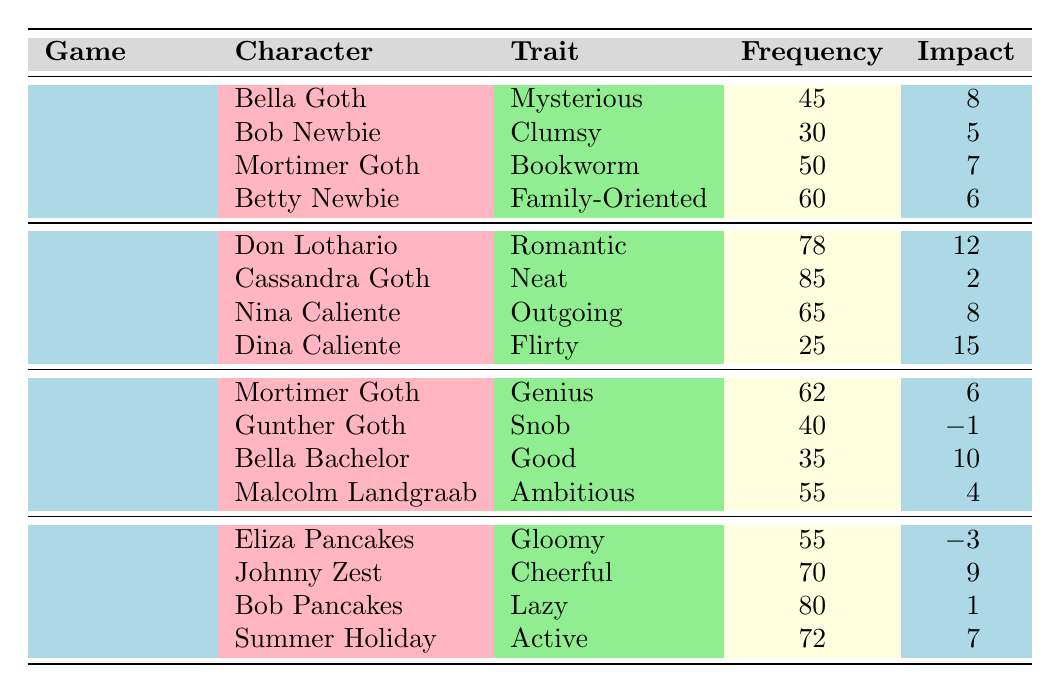What is the interaction with the highest frequency in The Sims 2? In The Sims 2, there are four characters listed. The frequencies of their interactions are: Don Lothario (78), Cassandra Goth (85), Nina Caliente (65), and Dina Caliente (25). The highest frequency is 85 associated with Cassandra Goth's interaction "Clean".
Answer: 85 Which character has the "Gloomy" trait in The Sims 4? In the table, under The Sims 4, the character listed with the "Gloomy" trait is Eliza Pancakes.
Answer: Eliza Pancakes What is the total frequency of interactions for characters in The Sims 3? The frequencies for The Sims 3 characters are: Mortimer Goth (62), Gunther Goth (40), Bella Bachelor (35), and Malcolm Landgraab (55). Adding these together gives: 62 + 40 + 35 + 55 = 192.
Answer: 192 Is there any character in The Sims 4 with a negative relationship impact? Looking at the relationship impact column for The Sims 4: Eliza Pancakes (-3), Johnny Zest (9), Bob Pancakes (1), and Summer Holiday (7). The presence of -3 for Eliza Pancakes confirms there is a character with a negative relationship impact.
Answer: Yes Which character from The Sims has the highest relationship impact? In The Sims, the characters are Bella Goth (8), Bob Newbie (5), Mortimer Goth (7), and Betty Newbie (6). The highest impact is 8 from Bella Goth's "Flirt" interaction.
Answer: Bella Goth What is the average frequency of interactions for characters in The Sims 3? The characters in The Sims 3 have the following frequencies: Mortimer Goth (62), Gunther Goth (40), Bella Bachelor (35), and Malcolm Landgraab (55). The total is 62 + 40 + 35 + 55 = 192. Dividing this by 4 (the number of characters) gives an average of 192/4 = 48.
Answer: 48 Which trait is associated with the character Johnny Zest? In the table under The Sims 4, the character Johnny Zest is associated with the "Cheerful" trait.
Answer: Cheerful How many interactions have a relationship impact of 9 or higher? We look at all characters: Johnny Zest (9), Don Lothario (12), and Dina Caliente (15). That gives us three interactions that have a relationship impact of 9 or higher.
Answer: 3 